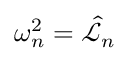<formula> <loc_0><loc_0><loc_500><loc_500>\omega _ { n } ^ { 2 } = \hat { \ m a t h s c r { L } } _ { n }</formula> 